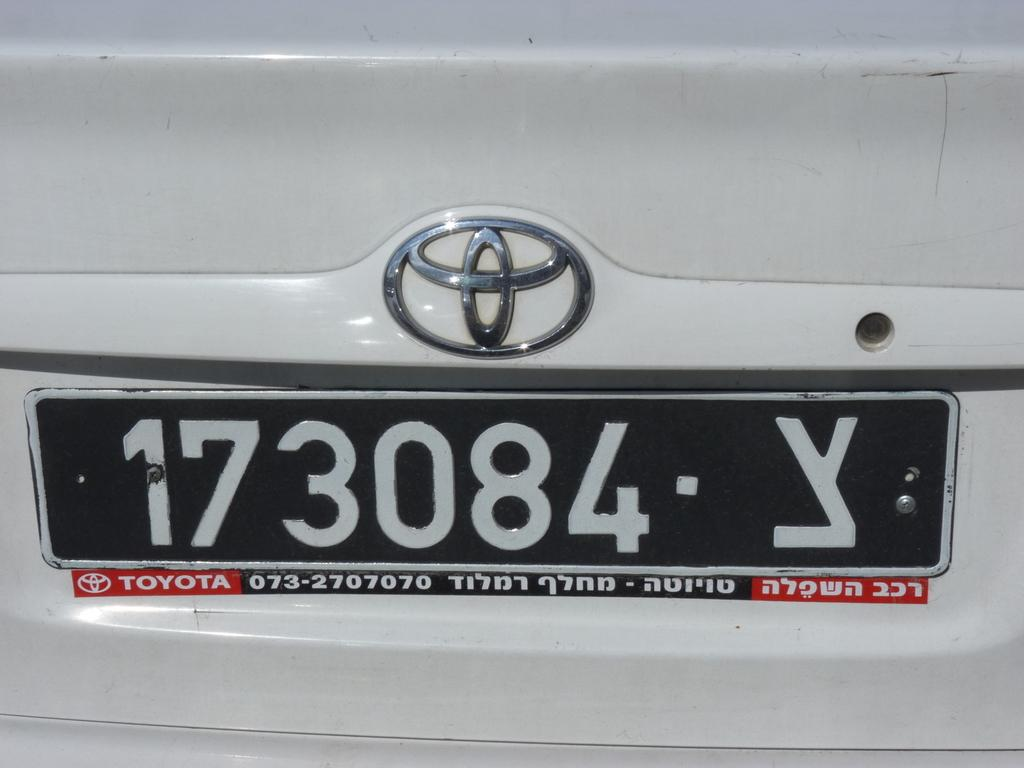<image>
Write a terse but informative summary of the picture. A white Toyota with a tag that reads 173084 Y. 